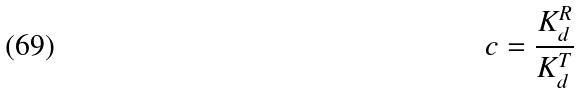<formula> <loc_0><loc_0><loc_500><loc_500>c = \frac { K _ { d } ^ { R } } { K _ { d } ^ { T } }</formula> 